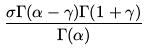Convert formula to latex. <formula><loc_0><loc_0><loc_500><loc_500>\frac { \sigma \Gamma ( \alpha - \gamma ) \Gamma ( 1 + \gamma ) } { \Gamma ( \alpha ) }</formula> 